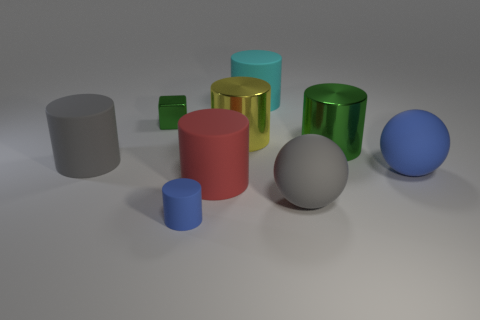How many other objects are the same material as the big blue ball?
Your answer should be very brief. 5. There is a big cyan rubber cylinder that is behind the blue matte thing to the right of the yellow cylinder; are there any large yellow objects that are behind it?
Your response must be concise. No. Is the tiny cube made of the same material as the blue cylinder?
Ensure brevity in your answer.  No. Is there anything else that is the same shape as the yellow shiny object?
Keep it short and to the point. Yes. The tiny object that is in front of the green thing that is on the right side of the tiny block is made of what material?
Provide a succinct answer. Rubber. What is the size of the rubber cylinder on the left side of the small metallic object?
Keep it short and to the point. Large. What is the color of the object that is both behind the tiny blue cylinder and in front of the red rubber cylinder?
Make the answer very short. Gray. There is a rubber ball on the left side of the green cylinder; does it have the same size as the blue rubber cylinder?
Make the answer very short. No. There is a shiny thing to the left of the blue rubber cylinder; are there any big red rubber cylinders that are behind it?
Offer a very short reply. No. What is the big blue thing made of?
Provide a succinct answer. Rubber. 